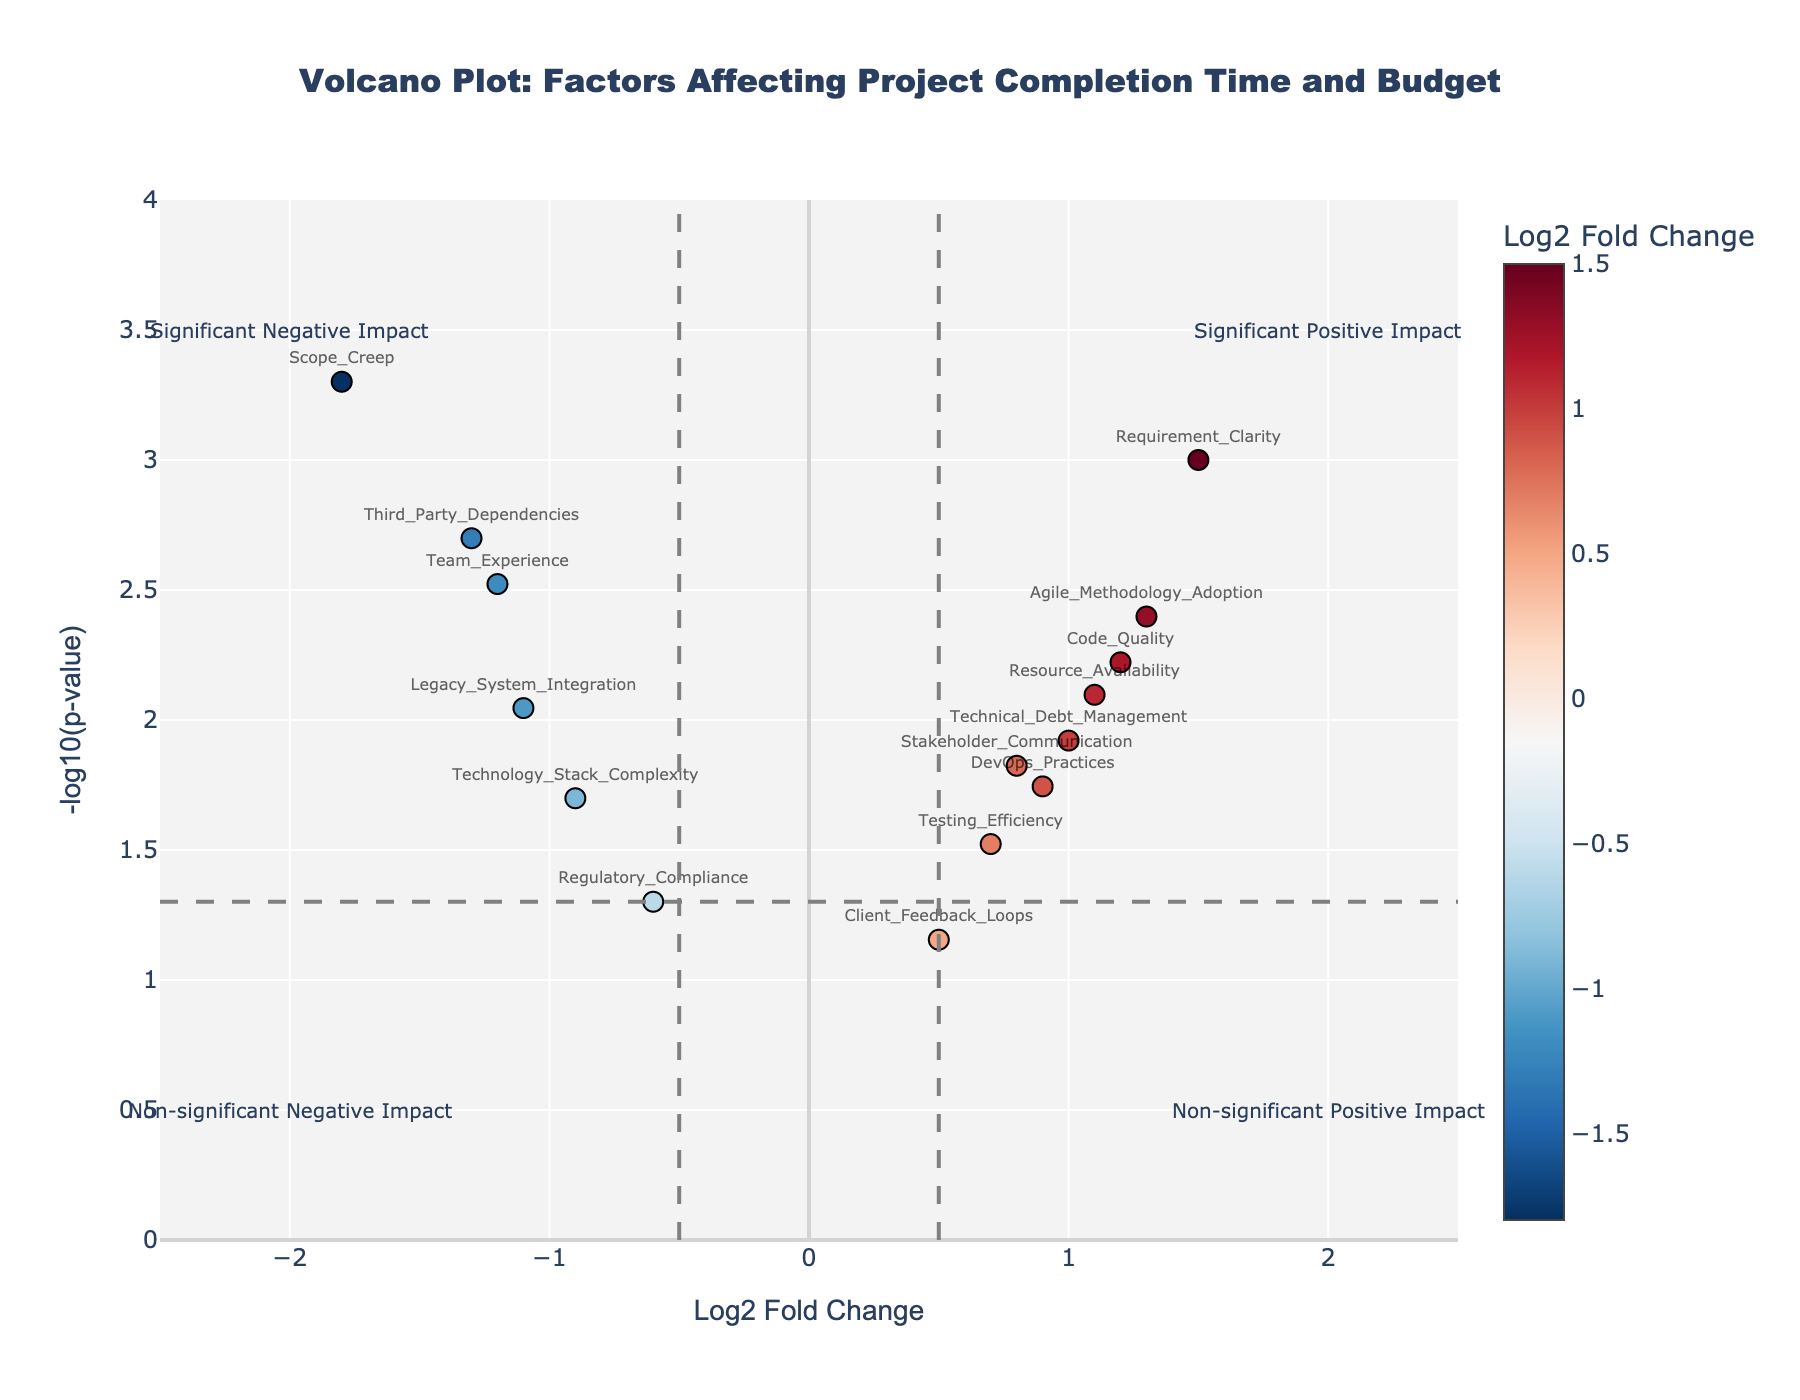What is the title of the Volcano Plot? The title of the volcano plot is usually found at the top of the plot in a larger font size and often provides an immediate summary of what the plot represents. In this plot, the title is clearly stated.
Answer: Volcano Plot: Factors Affecting Project Completion Time and Budget How many data points are plotted on the Volcano Plot? Each factor affecting project completion time and budget is represented as a data point on the plot. By counting the number of factors listed in the hover text or markers, you can determine the number of data points. There are 15 factors listed.
Answer: 15 Which factor shows the most significant negative impact on project completion time and budget? A more negative log2 fold change and a lower p-value (higher -log10(p-value)) indicate a more significant negative impact. Scope Creep has a log2 fold change of -1.8 and one of the lowest p-values (higher -log10(p-value)).
Answer: Scope Creep Which factor has the highest -log10(p-value)? The highest -log10(p-value) can be identified by looking at the y-axis for the highest point. Requirement_Clarity appears at the highest point on the y-axis, indicating the lowest p-value.
Answer: Requirement_Clarity Between Team_Experience and Technology_Stack_Complexity, which factor has a lower p-value? To find the lower p-value, compare the -log10(p-value) of each factor. The factor with a higher -log10(p-value) value has a lower p-value. Team_Experience has a -log10(p-value) of 2.52 while Technology_Stack_Complexity has 1.70.
Answer: Team_Experience Which factor shows the most significant positive impact on project completion time and budget? The highest log2 fold change and a low p-value (higher -log10(p-value)) indicate the most significant positive impact. Requirement_Clarity stands out with a log2 fold change of 1.5 and one of the highest -log10(p-value).
Answer: Requirement_Clarity How many factors have a statistically significant impact (p-value < 0.05) on project completion time and budget? The dashed horizontal line indicates the p-value threshold of 0.05. Any points above this line are statistically significant. There are 13 factors above this line.
Answer: 13 Are there any factors with non-significant positive impacts on project completion time and budget? These factors would be on the right side of the plot (positive log2 fold change) and below the p-value significance line. Client_Feedback_Loops fits this description with a positive log2 fold change and a p-value of 0.07, making it non-significant.
Answer: Yes, Client_Feedback_Loops Which factor has the smallest log2 fold change? The smallest log2 fold change can be identified as the factor closest to zero along the x-axis. Regulatory_Compliance has the smallest log2 fold change of -0.6.
Answer: Regulatory_Compliance 